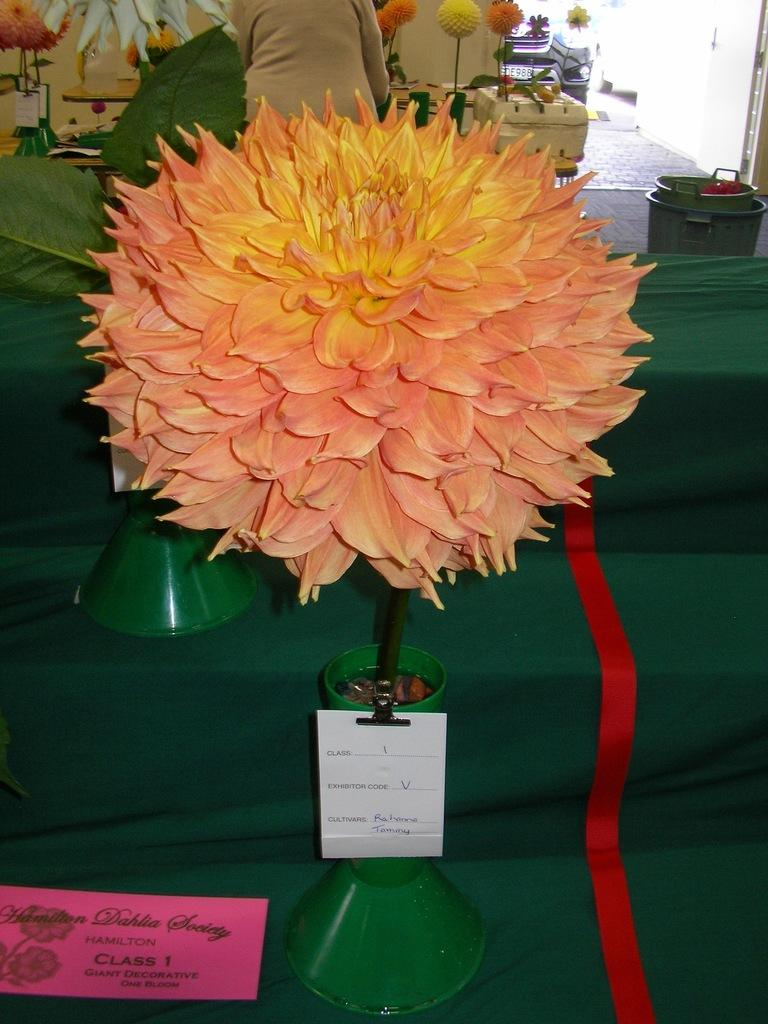What is located in the foreground of the image? There is a houseplant and a card on the steps in the foreground of the image. What can be seen in the background of the image? There are tubs and flower pots in the background of the image. Is there any human presence in the image? Yes, there is a person in the background of the image. Where was the image taken? The image was taken in a shop. What type of wrist support is visible in the image? There is no wrist support present in the image. What season is depicted in the image? The image does not depict a specific season, as there are no seasonal cues present. What is the person in the background of the image doing? The provided facts do not mention the person's actions or activities, so it cannot be determined from the image. 